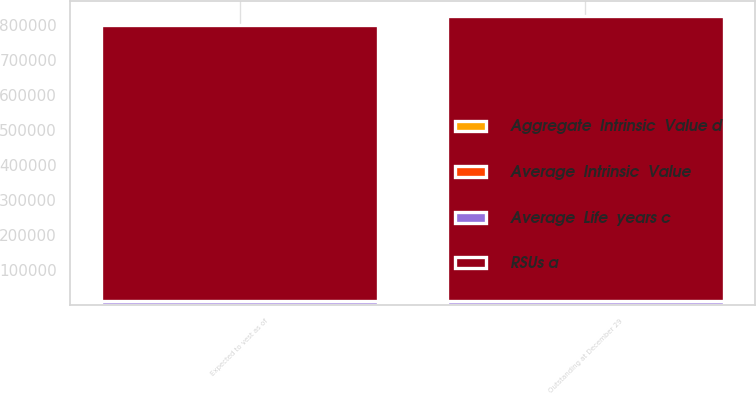Convert chart to OTSL. <chart><loc_0><loc_0><loc_500><loc_500><stacked_bar_chart><ecel><fcel>Outstanding at December 29<fcel>Expected to vest as of<nl><fcel>Average  Life  years c<fcel>11982<fcel>11616<nl><fcel>Average  Intrinsic  Value<fcel>65.6<fcel>65.58<nl><fcel>Aggregate  Intrinsic  Value d<fcel>1.49<fcel>1.34<nl><fcel>RSUs a<fcel>815051<fcel>790128<nl></chart> 